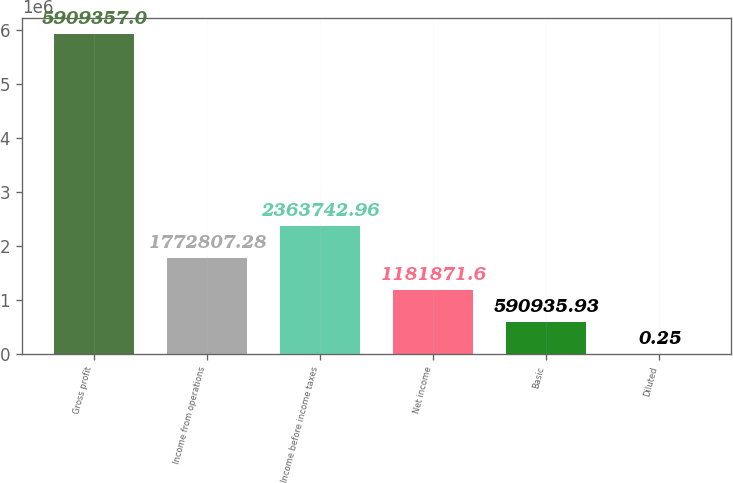Convert chart to OTSL. <chart><loc_0><loc_0><loc_500><loc_500><bar_chart><fcel>Gross profit<fcel>Income from operations<fcel>Income before income taxes<fcel>Net income<fcel>Basic<fcel>Diluted<nl><fcel>5.90936e+06<fcel>1.77281e+06<fcel>2.36374e+06<fcel>1.18187e+06<fcel>590936<fcel>0.25<nl></chart> 